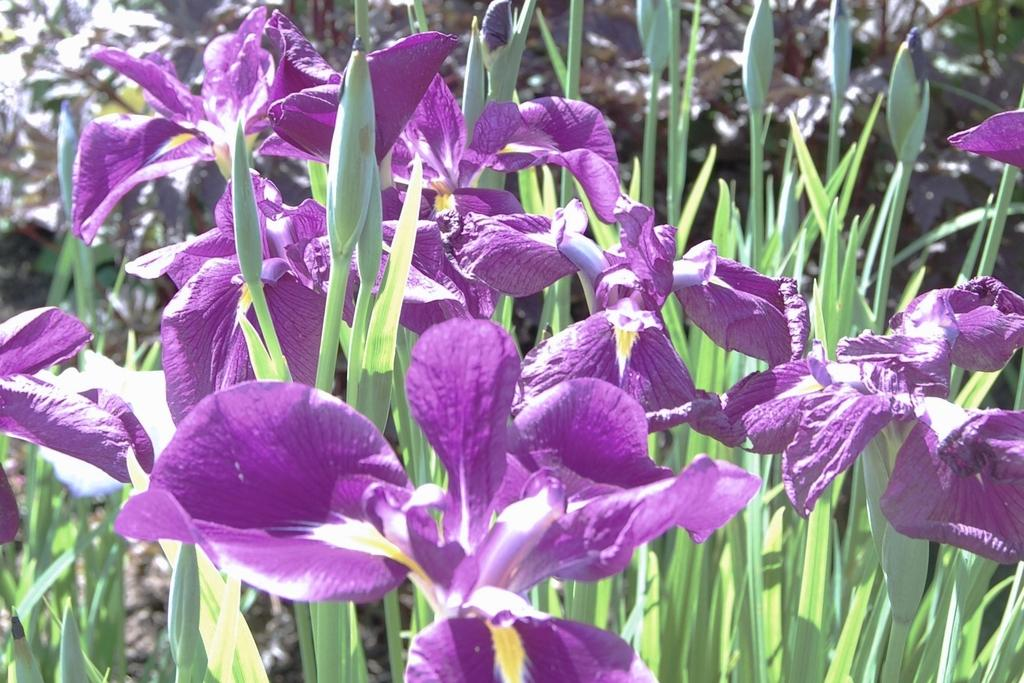What types of living organisms can be seen in the foreground of the image? There are flowers and plants in the foreground of the image. What can be seen in the background of the image? There are plants visible in the background of the image. How many types of plants are visible in the image? There are at least two types of plants visible, one in the foreground and one in the background. How many books are stacked on top of the slave in the image? There are no books or slaves present in the image; it features flowers and plants. 